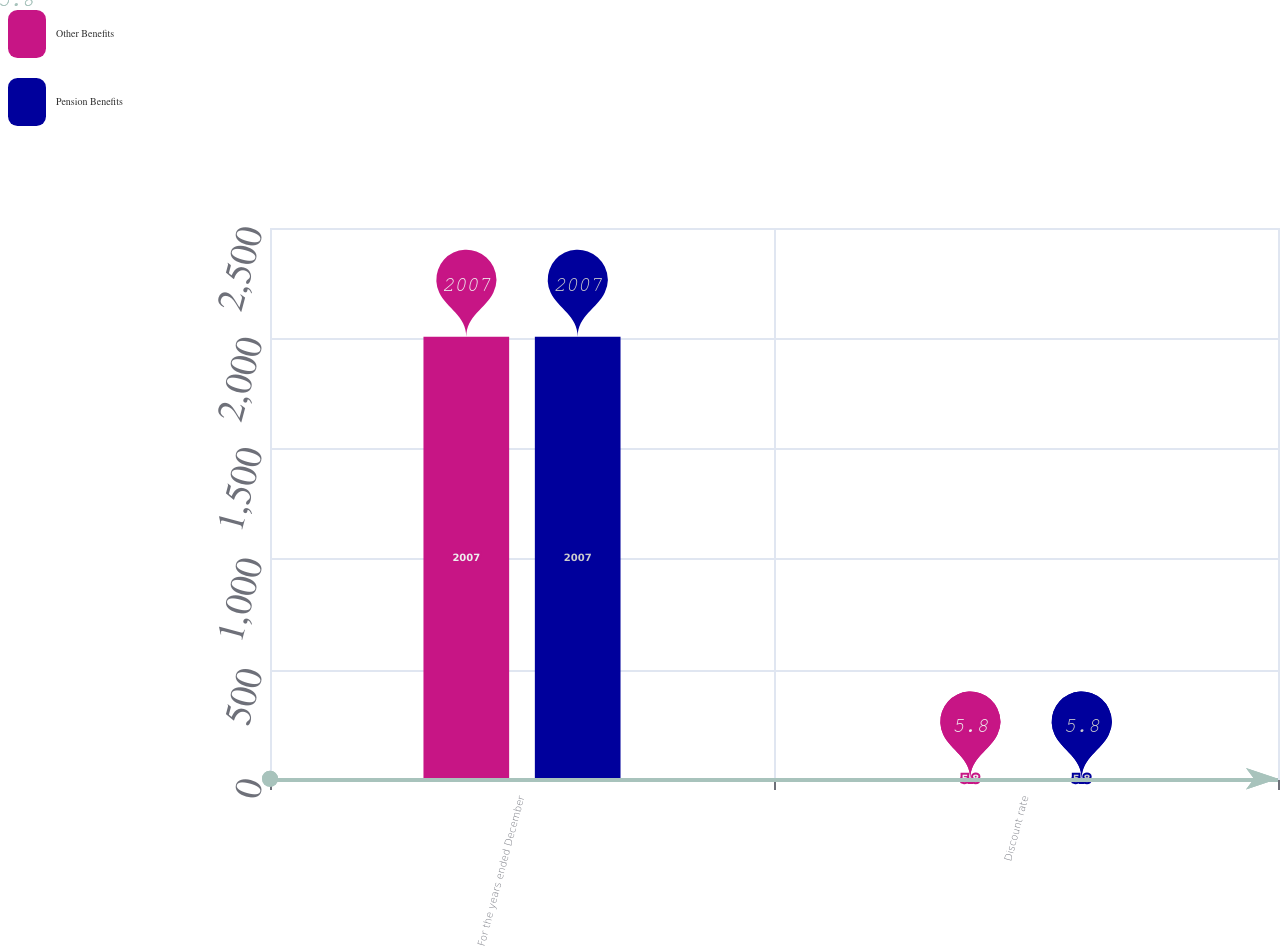<chart> <loc_0><loc_0><loc_500><loc_500><stacked_bar_chart><ecel><fcel>For the years ended December<fcel>Discount rate<nl><fcel>Other Benefits<fcel>2007<fcel>5.8<nl><fcel>Pension Benefits<fcel>2007<fcel>5.8<nl></chart> 